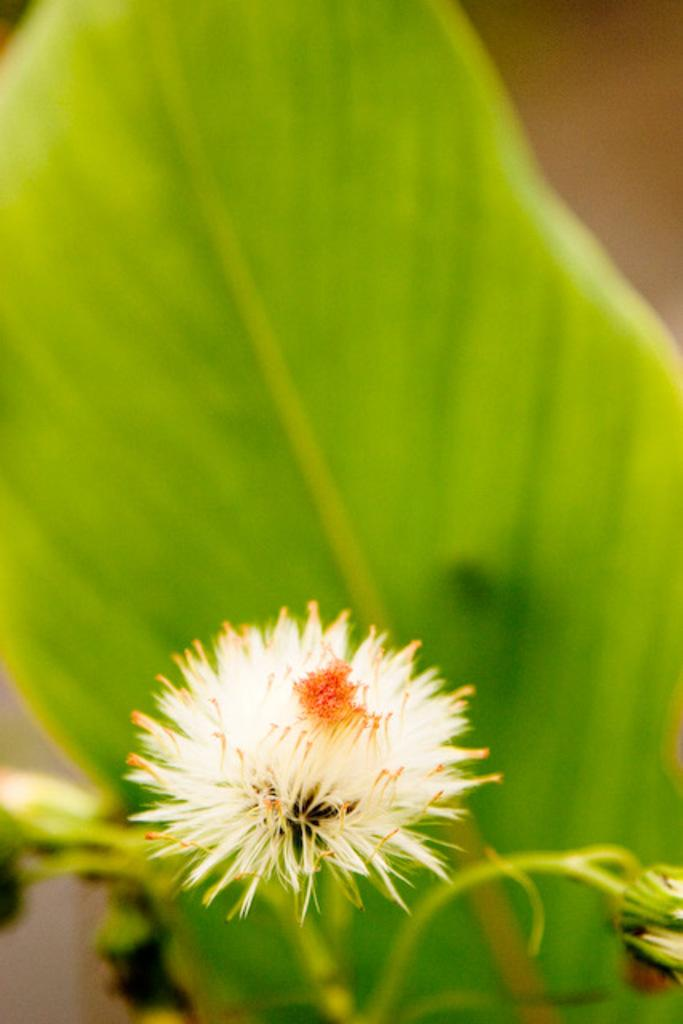What type of floral elements are present at the bottom of the picture? There are buds and a flower in white color at the bottom of the picture. What color is the leaf visible in the background? The leaf in the background is green. How would you describe the background of the image? The background of the image is blurred. How many records can be seen stacked on the chickens in the image? There are no records or chickens present in the image. Is there a skateboard visible near the flower in the image? There is no skateboard visible in the image; it only features buds, a white flower, and a green leaf. 